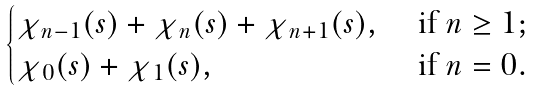<formula> <loc_0><loc_0><loc_500><loc_500>\begin{cases} \chi _ { n - 1 } ( s ) + \chi _ { n } ( s ) + \chi _ { n + 1 } ( s ) , & \text { if $n\geq 1$;} \\ \chi _ { 0 } ( s ) + \chi _ { 1 } ( s ) , & \text { if $n=0$.} \end{cases}</formula> 